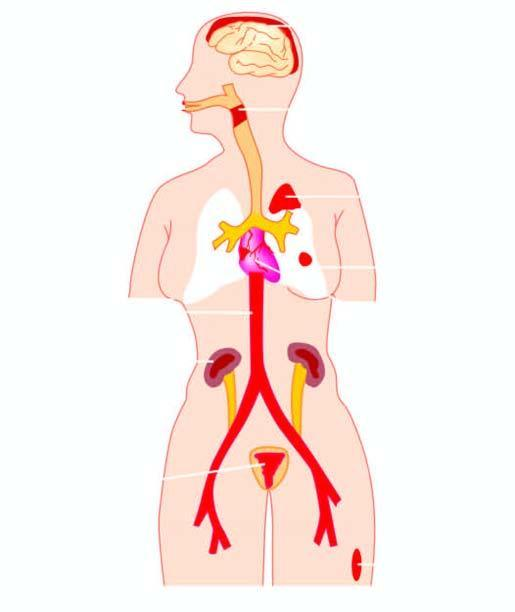what is diseases caused by?
Answer the question using a single word or phrase. Streptococci 